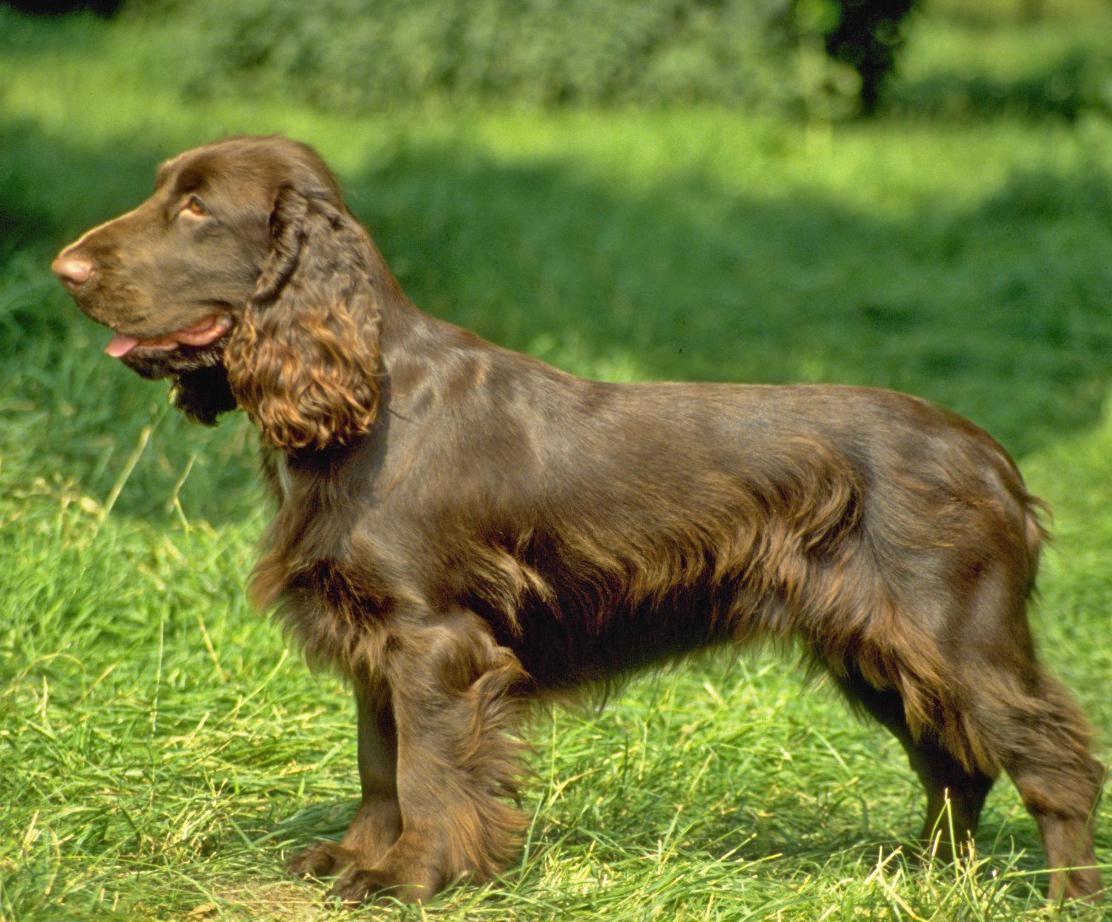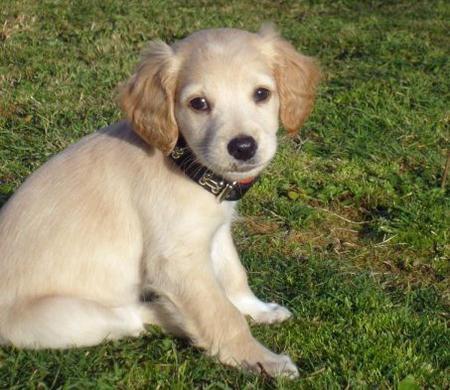The first image is the image on the left, the second image is the image on the right. Examine the images to the left and right. Is the description "There are no fewer than two dogs out doors in the image on the left." accurate? Answer yes or no. No. The first image is the image on the left, the second image is the image on the right. Evaluate the accuracy of this statement regarding the images: "At least three dogs, all of them the same breed, but different colors, are in one image.". Is it true? Answer yes or no. No. 